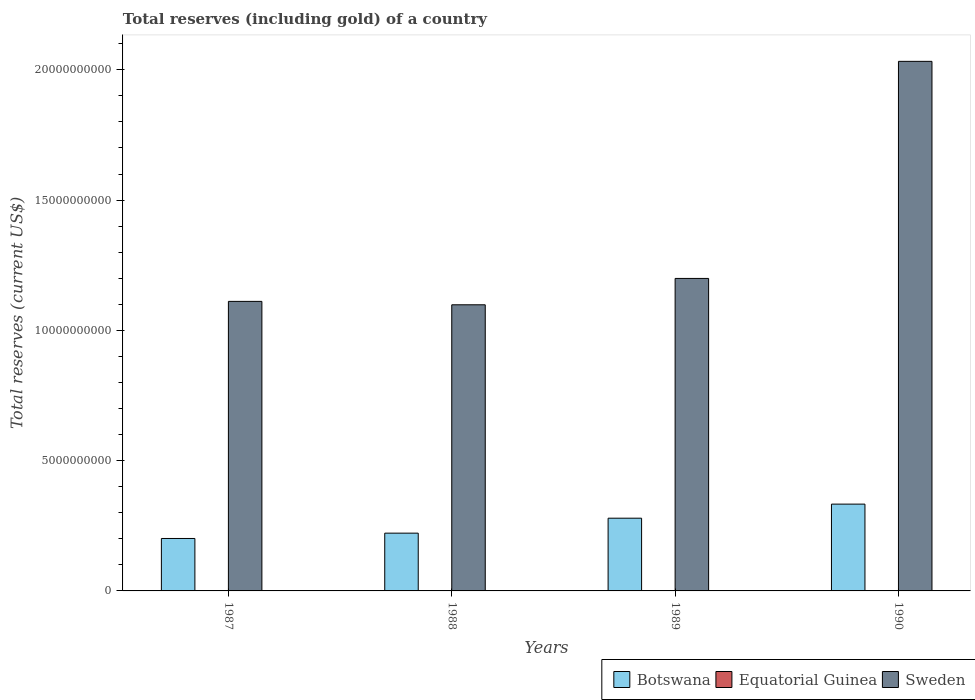How many groups of bars are there?
Provide a succinct answer. 4. How many bars are there on the 1st tick from the left?
Provide a short and direct response. 3. What is the label of the 3rd group of bars from the left?
Provide a succinct answer. 1989. In how many cases, is the number of bars for a given year not equal to the number of legend labels?
Offer a terse response. 0. What is the total reserves (including gold) in Sweden in 1990?
Your answer should be very brief. 2.03e+1. Across all years, what is the maximum total reserves (including gold) in Botswana?
Offer a terse response. 3.33e+09. Across all years, what is the minimum total reserves (including gold) in Botswana?
Make the answer very short. 2.01e+09. In which year was the total reserves (including gold) in Botswana maximum?
Provide a succinct answer. 1990. In which year was the total reserves (including gold) in Botswana minimum?
Your response must be concise. 1987. What is the total total reserves (including gold) in Equatorial Guinea in the graph?
Your answer should be very brief. 1.27e+07. What is the difference between the total reserves (including gold) in Botswana in 1987 and that in 1989?
Offer a terse response. -7.78e+08. What is the difference between the total reserves (including gold) in Botswana in 1988 and the total reserves (including gold) in Sweden in 1989?
Your answer should be very brief. -9.78e+09. What is the average total reserves (including gold) in Equatorial Guinea per year?
Make the answer very short. 3.19e+06. In the year 1988, what is the difference between the total reserves (including gold) in Sweden and total reserves (including gold) in Equatorial Guinea?
Your response must be concise. 1.10e+1. What is the ratio of the total reserves (including gold) in Sweden in 1988 to that in 1989?
Make the answer very short. 0.92. Is the total reserves (including gold) in Sweden in 1989 less than that in 1990?
Keep it short and to the point. Yes. Is the difference between the total reserves (including gold) in Sweden in 1987 and 1989 greater than the difference between the total reserves (including gold) in Equatorial Guinea in 1987 and 1989?
Make the answer very short. No. What is the difference between the highest and the second highest total reserves (including gold) in Botswana?
Provide a short and direct response. 5.40e+08. What is the difference between the highest and the lowest total reserves (including gold) in Botswana?
Provide a short and direct response. 1.32e+09. In how many years, is the total reserves (including gold) in Equatorial Guinea greater than the average total reserves (including gold) in Equatorial Guinea taken over all years?
Keep it short and to the point. 2. Is it the case that in every year, the sum of the total reserves (including gold) in Equatorial Guinea and total reserves (including gold) in Botswana is greater than the total reserves (including gold) in Sweden?
Your answer should be compact. No. Are all the bars in the graph horizontal?
Provide a short and direct response. No. How many years are there in the graph?
Offer a very short reply. 4. Are the values on the major ticks of Y-axis written in scientific E-notation?
Provide a succinct answer. No. Does the graph contain grids?
Make the answer very short. No. Where does the legend appear in the graph?
Ensure brevity in your answer.  Bottom right. How many legend labels are there?
Offer a terse response. 3. How are the legend labels stacked?
Your response must be concise. Horizontal. What is the title of the graph?
Provide a succinct answer. Total reserves (including gold) of a country. Does "Equatorial Guinea" appear as one of the legend labels in the graph?
Your answer should be compact. Yes. What is the label or title of the X-axis?
Offer a terse response. Years. What is the label or title of the Y-axis?
Your answer should be compact. Total reserves (current US$). What is the Total reserves (current US$) of Botswana in 1987?
Your response must be concise. 2.01e+09. What is the Total reserves (current US$) of Equatorial Guinea in 1987?
Ensure brevity in your answer.  5.69e+05. What is the Total reserves (current US$) of Sweden in 1987?
Provide a short and direct response. 1.11e+1. What is the Total reserves (current US$) of Botswana in 1988?
Your response must be concise. 2.22e+09. What is the Total reserves (current US$) in Equatorial Guinea in 1988?
Provide a succinct answer. 5.50e+06. What is the Total reserves (current US$) in Sweden in 1988?
Give a very brief answer. 1.10e+1. What is the Total reserves (current US$) in Botswana in 1989?
Ensure brevity in your answer.  2.79e+09. What is the Total reserves (current US$) in Equatorial Guinea in 1989?
Your response must be concise. 5.97e+06. What is the Total reserves (current US$) in Sweden in 1989?
Provide a succinct answer. 1.20e+1. What is the Total reserves (current US$) of Botswana in 1990?
Offer a very short reply. 3.33e+09. What is the Total reserves (current US$) in Equatorial Guinea in 1990?
Provide a short and direct response. 7.07e+05. What is the Total reserves (current US$) of Sweden in 1990?
Your answer should be very brief. 2.03e+1. Across all years, what is the maximum Total reserves (current US$) in Botswana?
Give a very brief answer. 3.33e+09. Across all years, what is the maximum Total reserves (current US$) in Equatorial Guinea?
Provide a short and direct response. 5.97e+06. Across all years, what is the maximum Total reserves (current US$) in Sweden?
Provide a succinct answer. 2.03e+1. Across all years, what is the minimum Total reserves (current US$) of Botswana?
Provide a short and direct response. 2.01e+09. Across all years, what is the minimum Total reserves (current US$) in Equatorial Guinea?
Offer a very short reply. 5.69e+05. Across all years, what is the minimum Total reserves (current US$) of Sweden?
Offer a very short reply. 1.10e+1. What is the total Total reserves (current US$) in Botswana in the graph?
Your response must be concise. 1.04e+1. What is the total Total reserves (current US$) of Equatorial Guinea in the graph?
Offer a terse response. 1.27e+07. What is the total Total reserves (current US$) in Sweden in the graph?
Provide a succinct answer. 5.44e+1. What is the difference between the Total reserves (current US$) in Botswana in 1987 and that in 1988?
Give a very brief answer. -2.04e+08. What is the difference between the Total reserves (current US$) of Equatorial Guinea in 1987 and that in 1988?
Your answer should be very brief. -4.93e+06. What is the difference between the Total reserves (current US$) of Sweden in 1987 and that in 1988?
Your answer should be very brief. 1.31e+08. What is the difference between the Total reserves (current US$) in Botswana in 1987 and that in 1989?
Provide a short and direct response. -7.78e+08. What is the difference between the Total reserves (current US$) in Equatorial Guinea in 1987 and that in 1989?
Ensure brevity in your answer.  -5.40e+06. What is the difference between the Total reserves (current US$) in Sweden in 1987 and that in 1989?
Offer a very short reply. -8.81e+08. What is the difference between the Total reserves (current US$) in Botswana in 1987 and that in 1990?
Provide a succinct answer. -1.32e+09. What is the difference between the Total reserves (current US$) of Equatorial Guinea in 1987 and that in 1990?
Offer a very short reply. -1.38e+05. What is the difference between the Total reserves (current US$) in Sweden in 1987 and that in 1990?
Give a very brief answer. -9.21e+09. What is the difference between the Total reserves (current US$) in Botswana in 1988 and that in 1989?
Provide a short and direct response. -5.74e+08. What is the difference between the Total reserves (current US$) in Equatorial Guinea in 1988 and that in 1989?
Keep it short and to the point. -4.65e+05. What is the difference between the Total reserves (current US$) in Sweden in 1988 and that in 1989?
Make the answer very short. -1.01e+09. What is the difference between the Total reserves (current US$) of Botswana in 1988 and that in 1990?
Offer a terse response. -1.11e+09. What is the difference between the Total reserves (current US$) of Equatorial Guinea in 1988 and that in 1990?
Provide a short and direct response. 4.80e+06. What is the difference between the Total reserves (current US$) of Sweden in 1988 and that in 1990?
Your response must be concise. -9.34e+09. What is the difference between the Total reserves (current US$) of Botswana in 1989 and that in 1990?
Provide a short and direct response. -5.40e+08. What is the difference between the Total reserves (current US$) of Equatorial Guinea in 1989 and that in 1990?
Make the answer very short. 5.26e+06. What is the difference between the Total reserves (current US$) in Sweden in 1989 and that in 1990?
Your answer should be compact. -8.33e+09. What is the difference between the Total reserves (current US$) of Botswana in 1987 and the Total reserves (current US$) of Equatorial Guinea in 1988?
Offer a very short reply. 2.01e+09. What is the difference between the Total reserves (current US$) of Botswana in 1987 and the Total reserves (current US$) of Sweden in 1988?
Your answer should be compact. -8.97e+09. What is the difference between the Total reserves (current US$) in Equatorial Guinea in 1987 and the Total reserves (current US$) in Sweden in 1988?
Provide a short and direct response. -1.10e+1. What is the difference between the Total reserves (current US$) in Botswana in 1987 and the Total reserves (current US$) in Equatorial Guinea in 1989?
Provide a short and direct response. 2.01e+09. What is the difference between the Total reserves (current US$) of Botswana in 1987 and the Total reserves (current US$) of Sweden in 1989?
Give a very brief answer. -9.98e+09. What is the difference between the Total reserves (current US$) of Equatorial Guinea in 1987 and the Total reserves (current US$) of Sweden in 1989?
Offer a terse response. -1.20e+1. What is the difference between the Total reserves (current US$) in Botswana in 1987 and the Total reserves (current US$) in Equatorial Guinea in 1990?
Offer a terse response. 2.01e+09. What is the difference between the Total reserves (current US$) in Botswana in 1987 and the Total reserves (current US$) in Sweden in 1990?
Your answer should be very brief. -1.83e+1. What is the difference between the Total reserves (current US$) of Equatorial Guinea in 1987 and the Total reserves (current US$) of Sweden in 1990?
Provide a succinct answer. -2.03e+1. What is the difference between the Total reserves (current US$) in Botswana in 1988 and the Total reserves (current US$) in Equatorial Guinea in 1989?
Make the answer very short. 2.21e+09. What is the difference between the Total reserves (current US$) of Botswana in 1988 and the Total reserves (current US$) of Sweden in 1989?
Your response must be concise. -9.78e+09. What is the difference between the Total reserves (current US$) of Equatorial Guinea in 1988 and the Total reserves (current US$) of Sweden in 1989?
Ensure brevity in your answer.  -1.20e+1. What is the difference between the Total reserves (current US$) of Botswana in 1988 and the Total reserves (current US$) of Equatorial Guinea in 1990?
Give a very brief answer. 2.22e+09. What is the difference between the Total reserves (current US$) of Botswana in 1988 and the Total reserves (current US$) of Sweden in 1990?
Provide a short and direct response. -1.81e+1. What is the difference between the Total reserves (current US$) of Equatorial Guinea in 1988 and the Total reserves (current US$) of Sweden in 1990?
Give a very brief answer. -2.03e+1. What is the difference between the Total reserves (current US$) of Botswana in 1989 and the Total reserves (current US$) of Equatorial Guinea in 1990?
Make the answer very short. 2.79e+09. What is the difference between the Total reserves (current US$) in Botswana in 1989 and the Total reserves (current US$) in Sweden in 1990?
Give a very brief answer. -1.75e+1. What is the difference between the Total reserves (current US$) in Equatorial Guinea in 1989 and the Total reserves (current US$) in Sweden in 1990?
Provide a short and direct response. -2.03e+1. What is the average Total reserves (current US$) in Botswana per year?
Provide a succinct answer. 2.59e+09. What is the average Total reserves (current US$) of Equatorial Guinea per year?
Your answer should be very brief. 3.19e+06. What is the average Total reserves (current US$) of Sweden per year?
Make the answer very short. 1.36e+1. In the year 1987, what is the difference between the Total reserves (current US$) of Botswana and Total reserves (current US$) of Equatorial Guinea?
Offer a terse response. 2.01e+09. In the year 1987, what is the difference between the Total reserves (current US$) of Botswana and Total reserves (current US$) of Sweden?
Offer a very short reply. -9.10e+09. In the year 1987, what is the difference between the Total reserves (current US$) in Equatorial Guinea and Total reserves (current US$) in Sweden?
Provide a succinct answer. -1.11e+1. In the year 1988, what is the difference between the Total reserves (current US$) of Botswana and Total reserves (current US$) of Equatorial Guinea?
Your response must be concise. 2.21e+09. In the year 1988, what is the difference between the Total reserves (current US$) of Botswana and Total reserves (current US$) of Sweden?
Ensure brevity in your answer.  -8.76e+09. In the year 1988, what is the difference between the Total reserves (current US$) of Equatorial Guinea and Total reserves (current US$) of Sweden?
Keep it short and to the point. -1.10e+1. In the year 1989, what is the difference between the Total reserves (current US$) in Botswana and Total reserves (current US$) in Equatorial Guinea?
Make the answer very short. 2.79e+09. In the year 1989, what is the difference between the Total reserves (current US$) of Botswana and Total reserves (current US$) of Sweden?
Provide a succinct answer. -9.20e+09. In the year 1989, what is the difference between the Total reserves (current US$) of Equatorial Guinea and Total reserves (current US$) of Sweden?
Your response must be concise. -1.20e+1. In the year 1990, what is the difference between the Total reserves (current US$) in Botswana and Total reserves (current US$) in Equatorial Guinea?
Provide a succinct answer. 3.33e+09. In the year 1990, what is the difference between the Total reserves (current US$) of Botswana and Total reserves (current US$) of Sweden?
Your response must be concise. -1.70e+1. In the year 1990, what is the difference between the Total reserves (current US$) in Equatorial Guinea and Total reserves (current US$) in Sweden?
Your answer should be very brief. -2.03e+1. What is the ratio of the Total reserves (current US$) of Botswana in 1987 to that in 1988?
Ensure brevity in your answer.  0.91. What is the ratio of the Total reserves (current US$) of Equatorial Guinea in 1987 to that in 1988?
Your answer should be compact. 0.1. What is the ratio of the Total reserves (current US$) in Sweden in 1987 to that in 1988?
Your response must be concise. 1.01. What is the ratio of the Total reserves (current US$) in Botswana in 1987 to that in 1989?
Ensure brevity in your answer.  0.72. What is the ratio of the Total reserves (current US$) of Equatorial Guinea in 1987 to that in 1989?
Offer a terse response. 0.1. What is the ratio of the Total reserves (current US$) of Sweden in 1987 to that in 1989?
Provide a short and direct response. 0.93. What is the ratio of the Total reserves (current US$) of Botswana in 1987 to that in 1990?
Your response must be concise. 0.6. What is the ratio of the Total reserves (current US$) of Equatorial Guinea in 1987 to that in 1990?
Keep it short and to the point. 0.8. What is the ratio of the Total reserves (current US$) of Sweden in 1987 to that in 1990?
Keep it short and to the point. 0.55. What is the ratio of the Total reserves (current US$) in Botswana in 1988 to that in 1989?
Your answer should be compact. 0.79. What is the ratio of the Total reserves (current US$) of Equatorial Guinea in 1988 to that in 1989?
Provide a succinct answer. 0.92. What is the ratio of the Total reserves (current US$) of Sweden in 1988 to that in 1989?
Give a very brief answer. 0.92. What is the ratio of the Total reserves (current US$) in Botswana in 1988 to that in 1990?
Provide a short and direct response. 0.67. What is the ratio of the Total reserves (current US$) in Equatorial Guinea in 1988 to that in 1990?
Offer a terse response. 7.79. What is the ratio of the Total reserves (current US$) of Sweden in 1988 to that in 1990?
Your answer should be very brief. 0.54. What is the ratio of the Total reserves (current US$) in Botswana in 1989 to that in 1990?
Make the answer very short. 0.84. What is the ratio of the Total reserves (current US$) of Equatorial Guinea in 1989 to that in 1990?
Keep it short and to the point. 8.44. What is the ratio of the Total reserves (current US$) of Sweden in 1989 to that in 1990?
Keep it short and to the point. 0.59. What is the difference between the highest and the second highest Total reserves (current US$) of Botswana?
Offer a terse response. 5.40e+08. What is the difference between the highest and the second highest Total reserves (current US$) of Equatorial Guinea?
Make the answer very short. 4.65e+05. What is the difference between the highest and the second highest Total reserves (current US$) in Sweden?
Your response must be concise. 8.33e+09. What is the difference between the highest and the lowest Total reserves (current US$) of Botswana?
Give a very brief answer. 1.32e+09. What is the difference between the highest and the lowest Total reserves (current US$) of Equatorial Guinea?
Give a very brief answer. 5.40e+06. What is the difference between the highest and the lowest Total reserves (current US$) of Sweden?
Your answer should be very brief. 9.34e+09. 